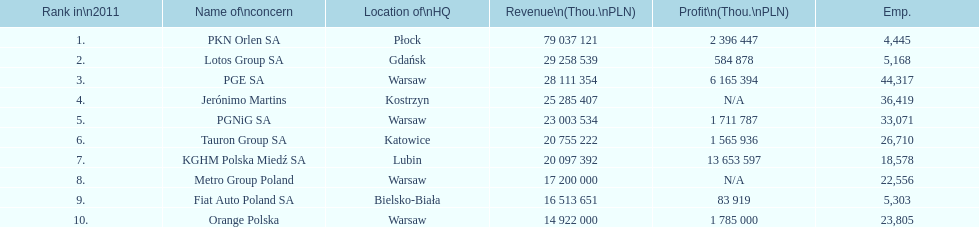Help me parse the entirety of this table. {'header': ['Rank in\\n2011', 'Name of\\nconcern', 'Location of\\nHQ', 'Revenue\\n(Thou.\\nPLN)', 'Profit\\n(Thou.\\nPLN)', 'Emp.'], 'rows': [['1.', 'PKN Orlen SA', 'Płock', '79 037 121', '2 396 447', '4,445'], ['2.', 'Lotos Group SA', 'Gdańsk', '29 258 539', '584 878', '5,168'], ['3.', 'PGE SA', 'Warsaw', '28 111 354', '6 165 394', '44,317'], ['4.', 'Jerónimo Martins', 'Kostrzyn', '25 285 407', 'N/A', '36,419'], ['5.', 'PGNiG SA', 'Warsaw', '23 003 534', '1 711 787', '33,071'], ['6.', 'Tauron Group SA', 'Katowice', '20 755 222', '1 565 936', '26,710'], ['7.', 'KGHM Polska Miedź SA', 'Lubin', '20 097 392', '13 653 597', '18,578'], ['8.', 'Metro Group Poland', 'Warsaw', '17 200 000', 'N/A', '22,556'], ['9.', 'Fiat Auto Poland SA', 'Bielsko-Biała', '16 513 651', '83 919', '5,303'], ['10.', 'Orange Polska', 'Warsaw', '14 922 000', '1 785 000', '23,805']]} How many companies had over $1,000,000 profit? 6. 